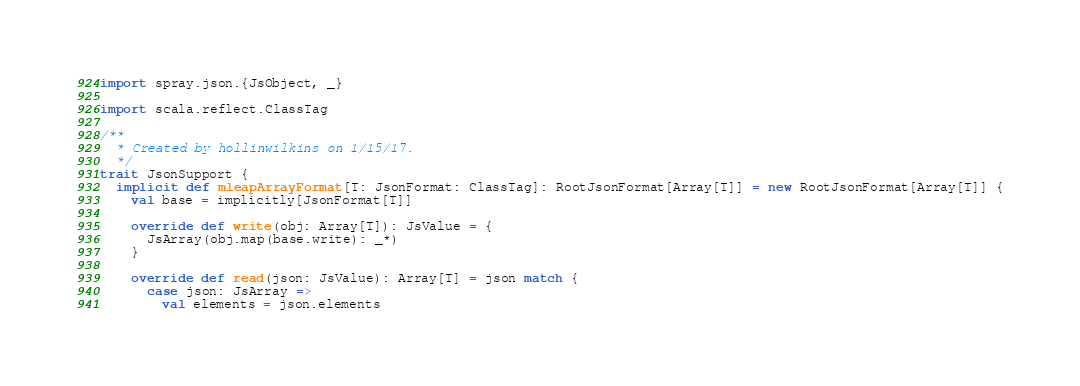Convert code to text. <code><loc_0><loc_0><loc_500><loc_500><_Scala_>import spray.json.{JsObject, _}

import scala.reflect.ClassTag

/**
  * Created by hollinwilkins on 1/15/17.
  */
trait JsonSupport {
  implicit def mleapArrayFormat[T: JsonFormat: ClassTag]: RootJsonFormat[Array[T]] = new RootJsonFormat[Array[T]] {
    val base = implicitly[JsonFormat[T]]

    override def write(obj: Array[T]): JsValue = {
      JsArray(obj.map(base.write): _*)
    }

    override def read(json: JsValue): Array[T] = json match {
      case json: JsArray =>
        val elements = json.elements</code> 